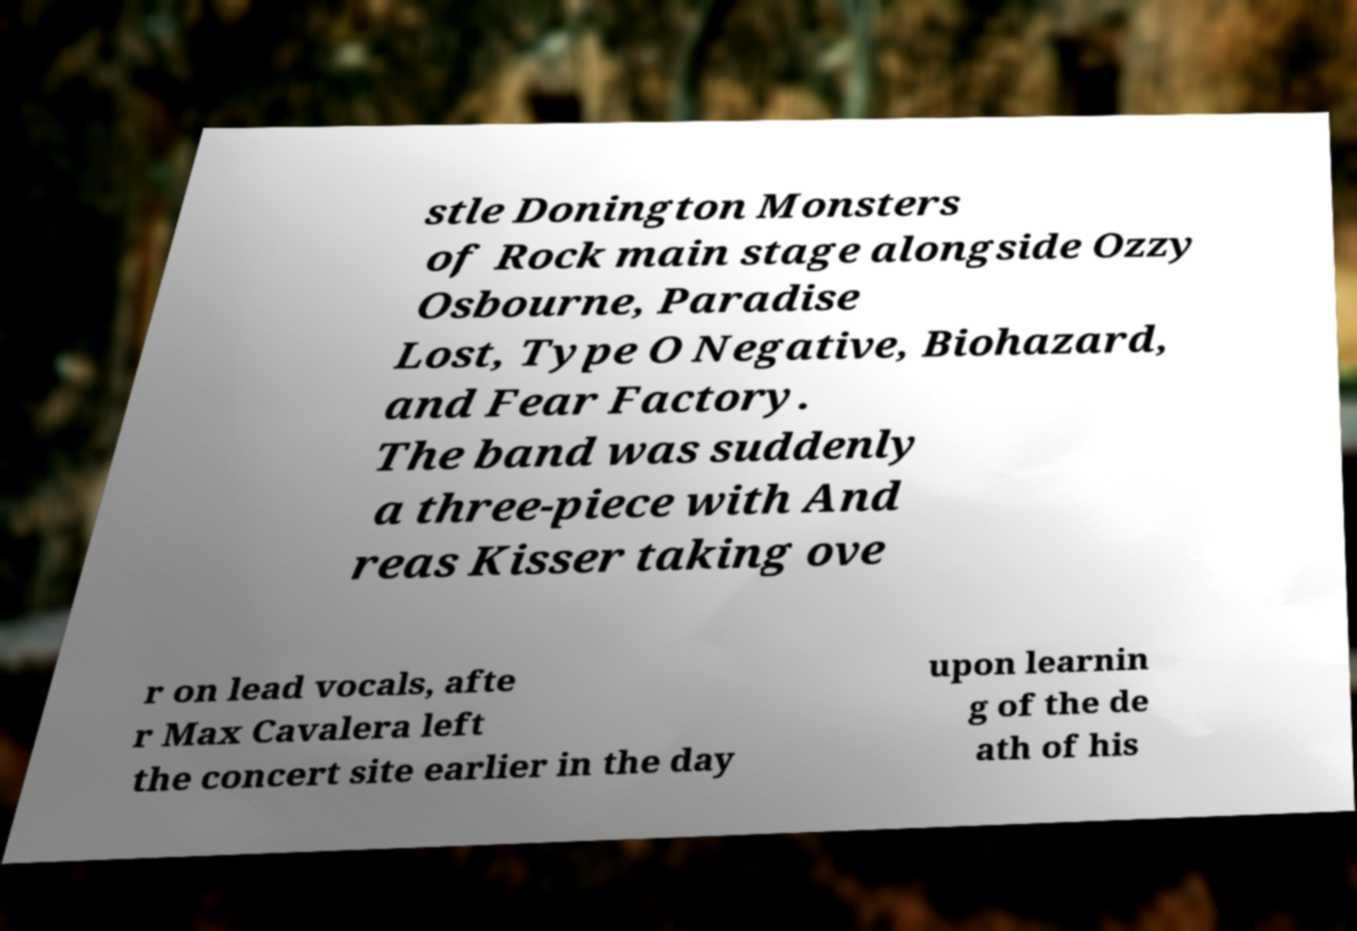There's text embedded in this image that I need extracted. Can you transcribe it verbatim? stle Donington Monsters of Rock main stage alongside Ozzy Osbourne, Paradise Lost, Type O Negative, Biohazard, and Fear Factory. The band was suddenly a three-piece with And reas Kisser taking ove r on lead vocals, afte r Max Cavalera left the concert site earlier in the day upon learnin g of the de ath of his 